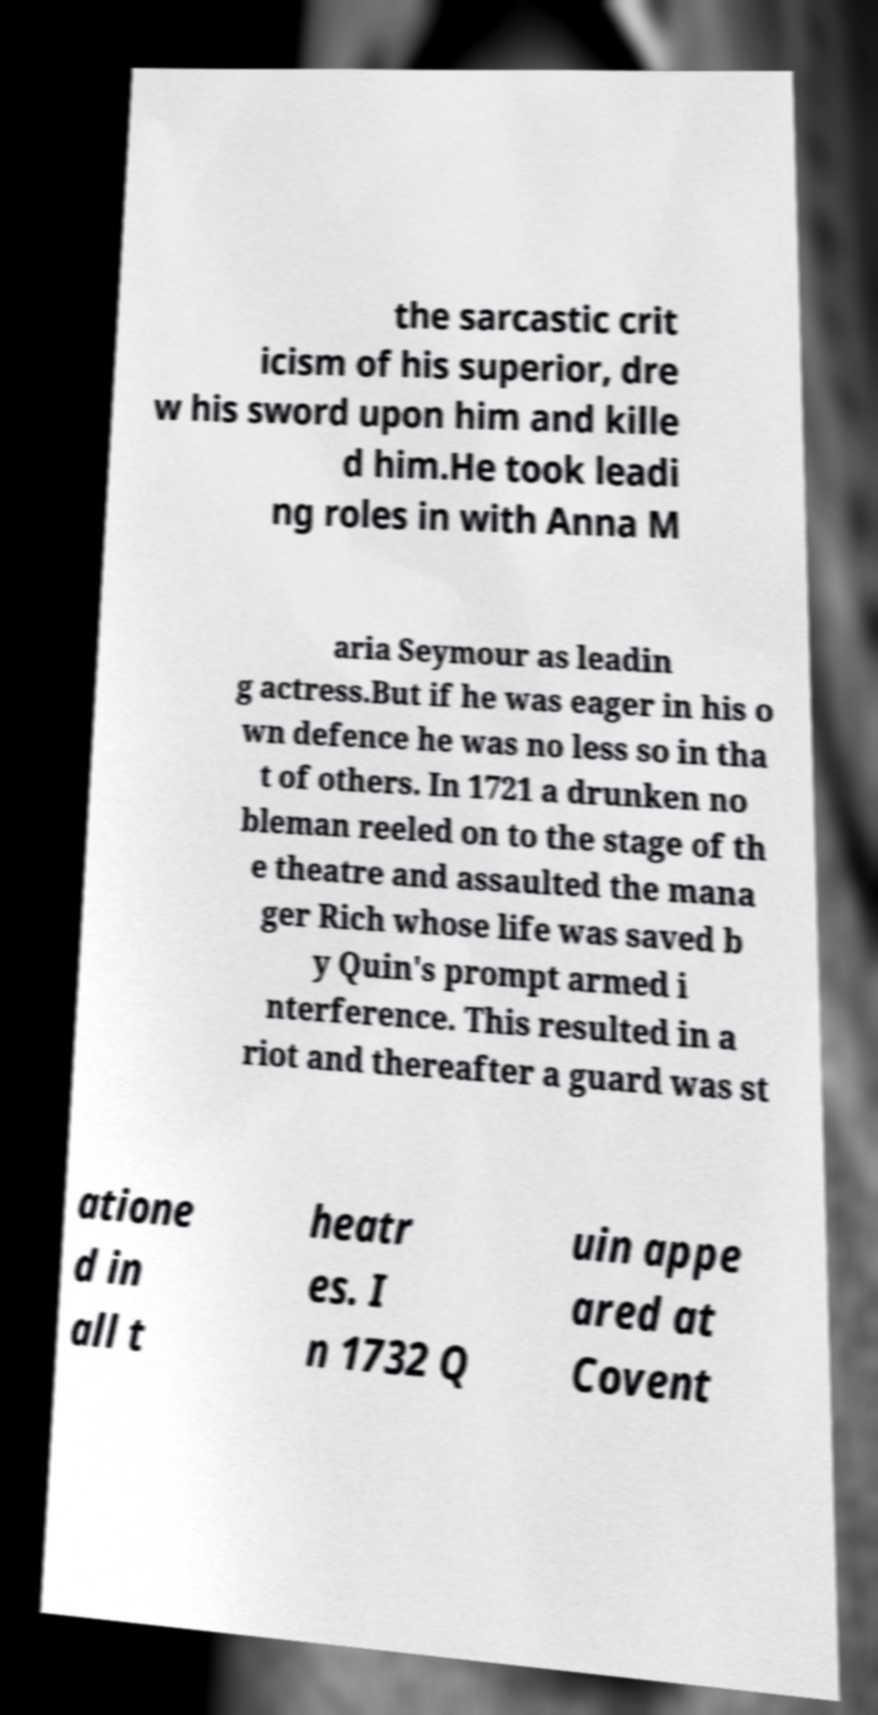For documentation purposes, I need the text within this image transcribed. Could you provide that? the sarcastic crit icism of his superior, dre w his sword upon him and kille d him.He took leadi ng roles in with Anna M aria Seymour as leadin g actress.But if he was eager in his o wn defence he was no less so in tha t of others. In 1721 a drunken no bleman reeled on to the stage of th e theatre and assaulted the mana ger Rich whose life was saved b y Quin's prompt armed i nterference. This resulted in a riot and thereafter a guard was st atione d in all t heatr es. I n 1732 Q uin appe ared at Covent 